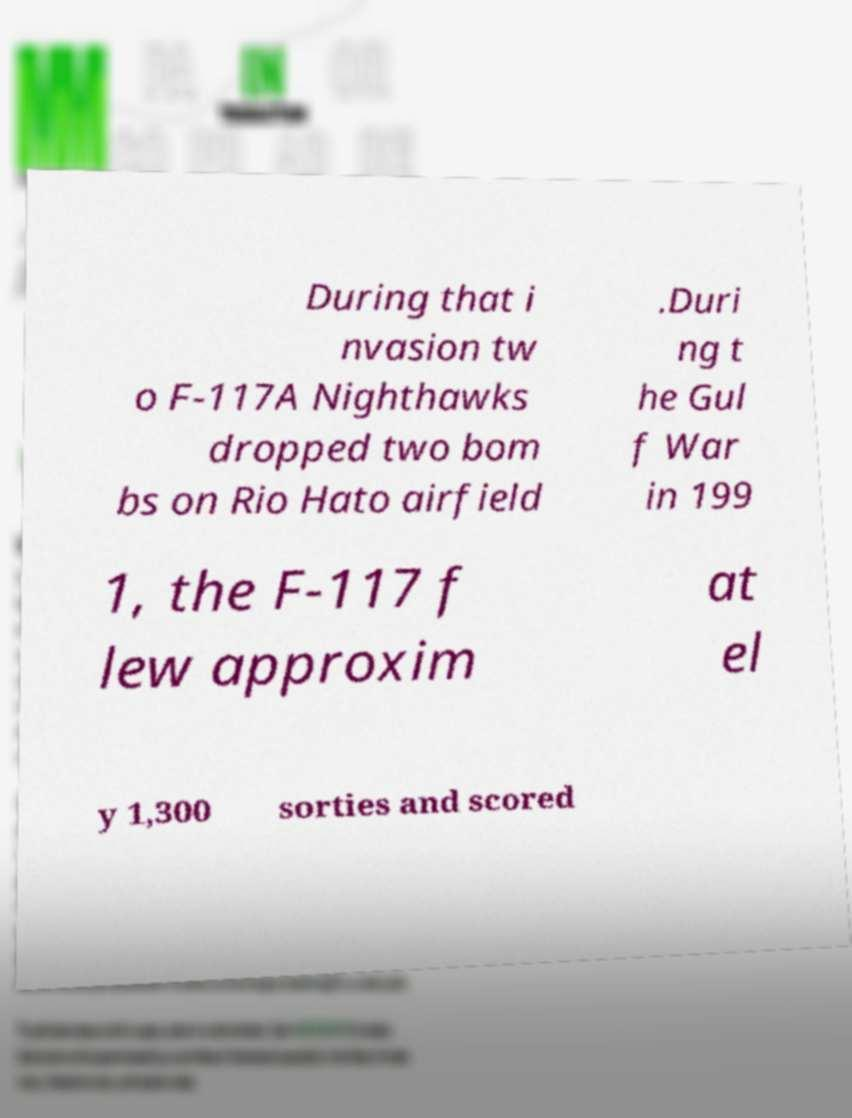I need the written content from this picture converted into text. Can you do that? During that i nvasion tw o F-117A Nighthawks dropped two bom bs on Rio Hato airfield .Duri ng t he Gul f War in 199 1, the F-117 f lew approxim at el y 1,300 sorties and scored 